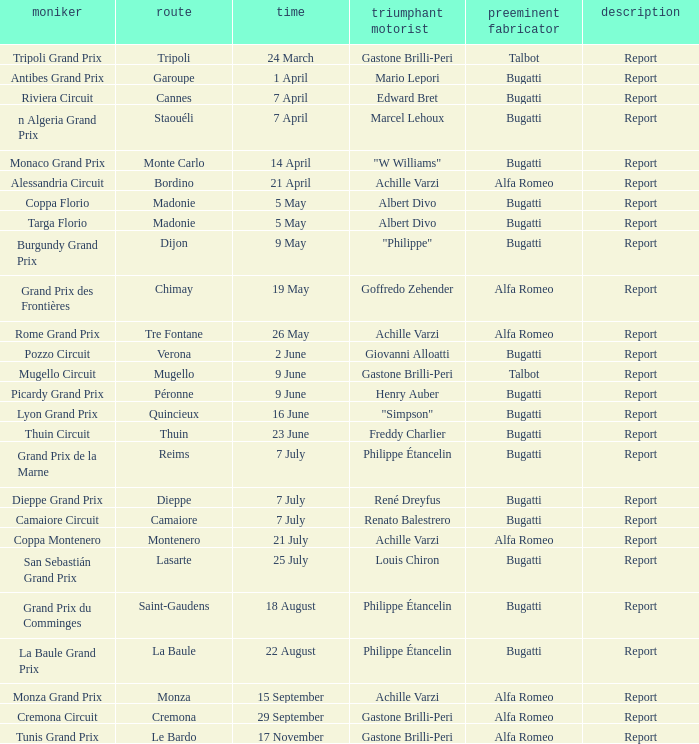What Circuit has a Date of 25 july? Lasarte. 